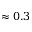Convert formula to latex. <formula><loc_0><loc_0><loc_500><loc_500>\approx 0 . 3</formula> 